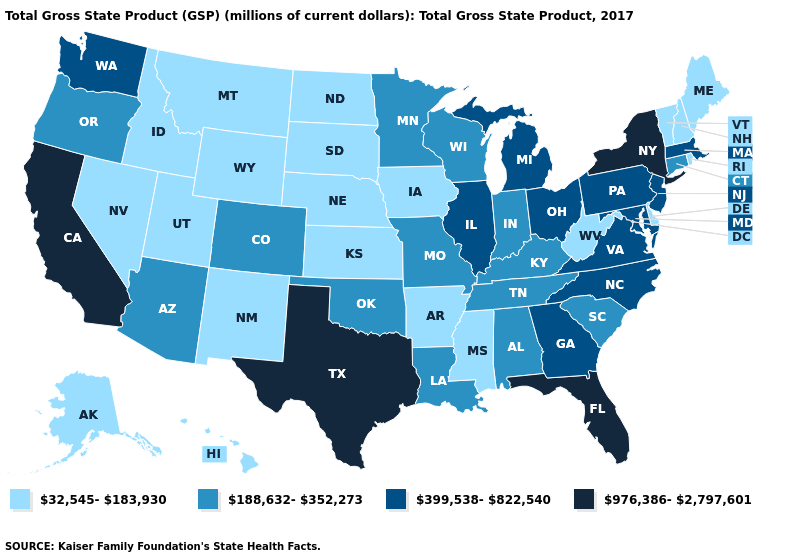Among the states that border Minnesota , does North Dakota have the highest value?
Keep it brief. No. Does New Jersey have the same value as West Virginia?
Be succinct. No. What is the lowest value in states that border Wisconsin?
Keep it brief. 32,545-183,930. What is the value of Georgia?
Be succinct. 399,538-822,540. What is the highest value in the USA?
Keep it brief. 976,386-2,797,601. Name the states that have a value in the range 976,386-2,797,601?
Short answer required. California, Florida, New York, Texas. Name the states that have a value in the range 32,545-183,930?
Quick response, please. Alaska, Arkansas, Delaware, Hawaii, Idaho, Iowa, Kansas, Maine, Mississippi, Montana, Nebraska, Nevada, New Hampshire, New Mexico, North Dakota, Rhode Island, South Dakota, Utah, Vermont, West Virginia, Wyoming. Among the states that border Mississippi , which have the lowest value?
Be succinct. Arkansas. Among the states that border New Jersey , does Delaware have the lowest value?
Keep it brief. Yes. Among the states that border Maryland , does West Virginia have the highest value?
Write a very short answer. No. What is the value of Connecticut?
Keep it brief. 188,632-352,273. Among the states that border South Dakota , does Minnesota have the lowest value?
Write a very short answer. No. Name the states that have a value in the range 976,386-2,797,601?
Keep it brief. California, Florida, New York, Texas. Does Connecticut have the lowest value in the Northeast?
Quick response, please. No. Among the states that border Vermont , which have the highest value?
Write a very short answer. New York. 